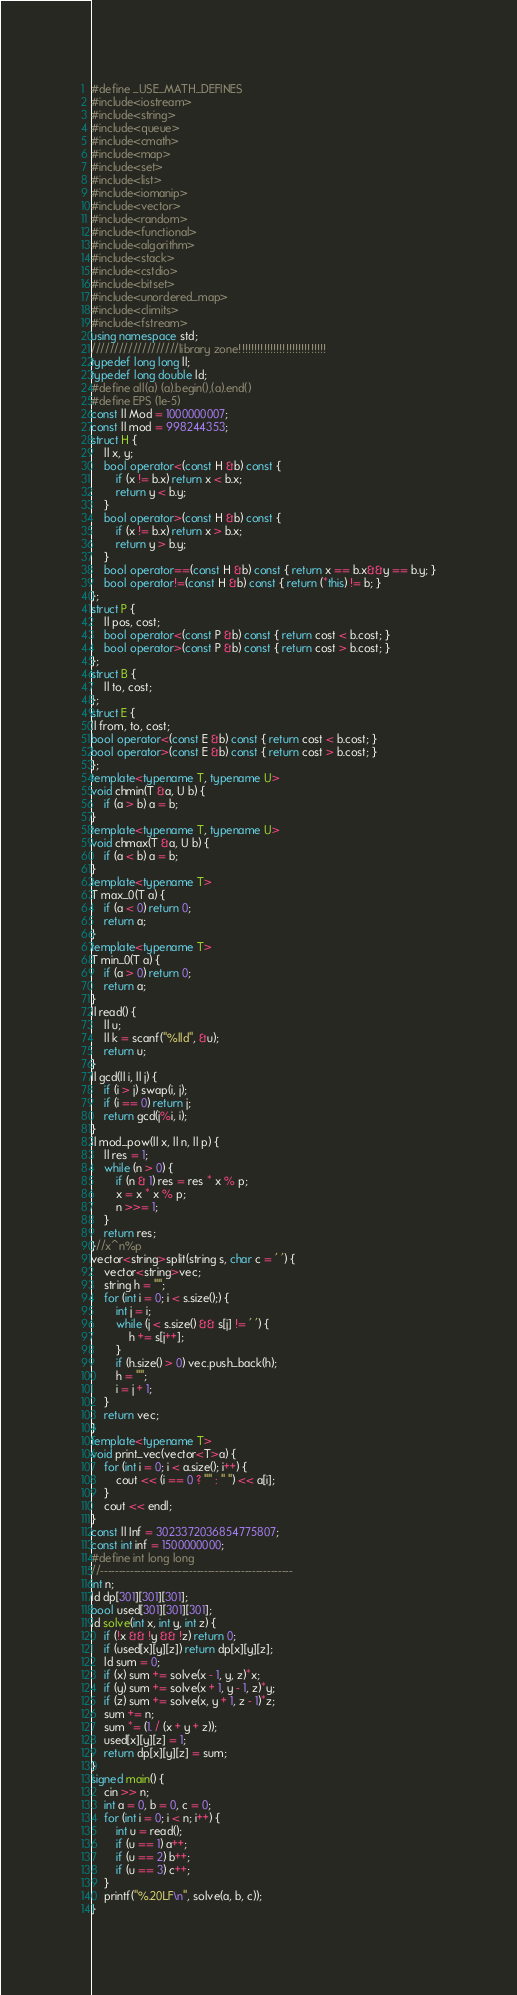Convert code to text. <code><loc_0><loc_0><loc_500><loc_500><_C++_>#define _USE_MATH_DEFINES
#include<iostream>
#include<string>
#include<queue>
#include<cmath>
#include<map>
#include<set>
#include<list>
#include<iomanip>
#include<vector>
#include<random>
#include<functional>
#include<algorithm>
#include<stack>
#include<cstdio>
#include<bitset>
#include<unordered_map>
#include<climits>
#include<fstream>
using namespace std;
///////////////////library zone!!!!!!!!!!!!!!!!!!!!!!!!!!!!
typedef long long ll;
typedef long double ld;
#define all(a) (a).begin(),(a).end()
#define EPS (1e-5)
const ll Mod = 1000000007;
const ll mod = 998244353;
struct H {
	ll x, y;
	bool operator<(const H &b) const {
		if (x != b.x) return x < b.x;
		return y < b.y;
	}
	bool operator>(const H &b) const {
		if (x != b.x) return x > b.x;
		return y > b.y;
	}
	bool operator==(const H &b) const { return x == b.x&&y == b.y; }
	bool operator!=(const H &b) const { return (*this) != b; }
};
struct P {
	ll pos, cost;
	bool operator<(const P &b) const { return cost < b.cost; }
	bool operator>(const P &b) const { return cost > b.cost; }
};
struct B {
	ll to, cost;
};
struct E {
ll from, to, cost;
bool operator<(const E &b) const { return cost < b.cost; }
bool operator>(const E &b) const { return cost > b.cost; }
};
template<typename T, typename U>
void chmin(T &a, U b) {
	if (a > b) a = b;
}
template<typename T, typename U>
void chmax(T &a, U b) {
	if (a < b) a = b;
}
template<typename T>
T max_0(T a) {
	if (a < 0) return 0;
	return a;
}
template<typename T>
T min_0(T a) {
	if (a > 0) return 0;
	return a;
}
ll read() {
	ll u;
	ll k = scanf("%lld", &u);
	return u;
}
ll gcd(ll i, ll j) {
	if (i > j) swap(i, j);
	if (i == 0) return j;
	return gcd(j%i, i);
}
ll mod_pow(ll x, ll n, ll p) {
	ll res = 1;
	while (n > 0) {
		if (n & 1) res = res * x % p;
		x = x * x % p;
		n >>= 1;
	}
	return res;
}//x^n%p
vector<string>split(string s, char c = ' ') {
	vector<string>vec;
	string h = "";
	for (int i = 0; i < s.size();) {
		int j = i;
		while (j < s.size() && s[j] != ' ') {
			h += s[j++];
		}
		if (h.size() > 0) vec.push_back(h);
		h = "";
		i = j + 1;
	}
	return vec;
}
template<typename T>
void print_vec(vector<T>a) {
	for (int i = 0; i < a.size(); i++) {
		cout << (i == 0 ? "" : " ") << a[i];
	}
	cout << endl;
}
const ll Inf = 3023372036854775807;
const int inf = 1500000000;
#define int long long
//----------------------------------------------------
int n;
ld dp[301][301][301];
bool used[301][301][301];
ld solve(int x, int y, int z) {
	if (!x && !y && !z) return 0;
	if (used[x][y][z]) return dp[x][y][z];
	ld sum = 0;
	if (x) sum += solve(x - 1, y, z)*x;
	if (y) sum += solve(x + 1, y - 1, z)*y;
	if (z) sum += solve(x, y + 1, z - 1)*z;
	sum += n;
	sum *= (1. / (x + y + z));
	used[x][y][z] = 1;
	return dp[x][y][z] = sum;
}
signed main() {
	cin >> n;
	int a = 0, b = 0, c = 0;
	for (int i = 0; i < n; i++) {
		int u = read();
		if (u == 1) a++;
		if (u == 2) b++;
		if (u == 3) c++;
	}
	printf("%.20LF\n", solve(a, b, c));
}</code> 